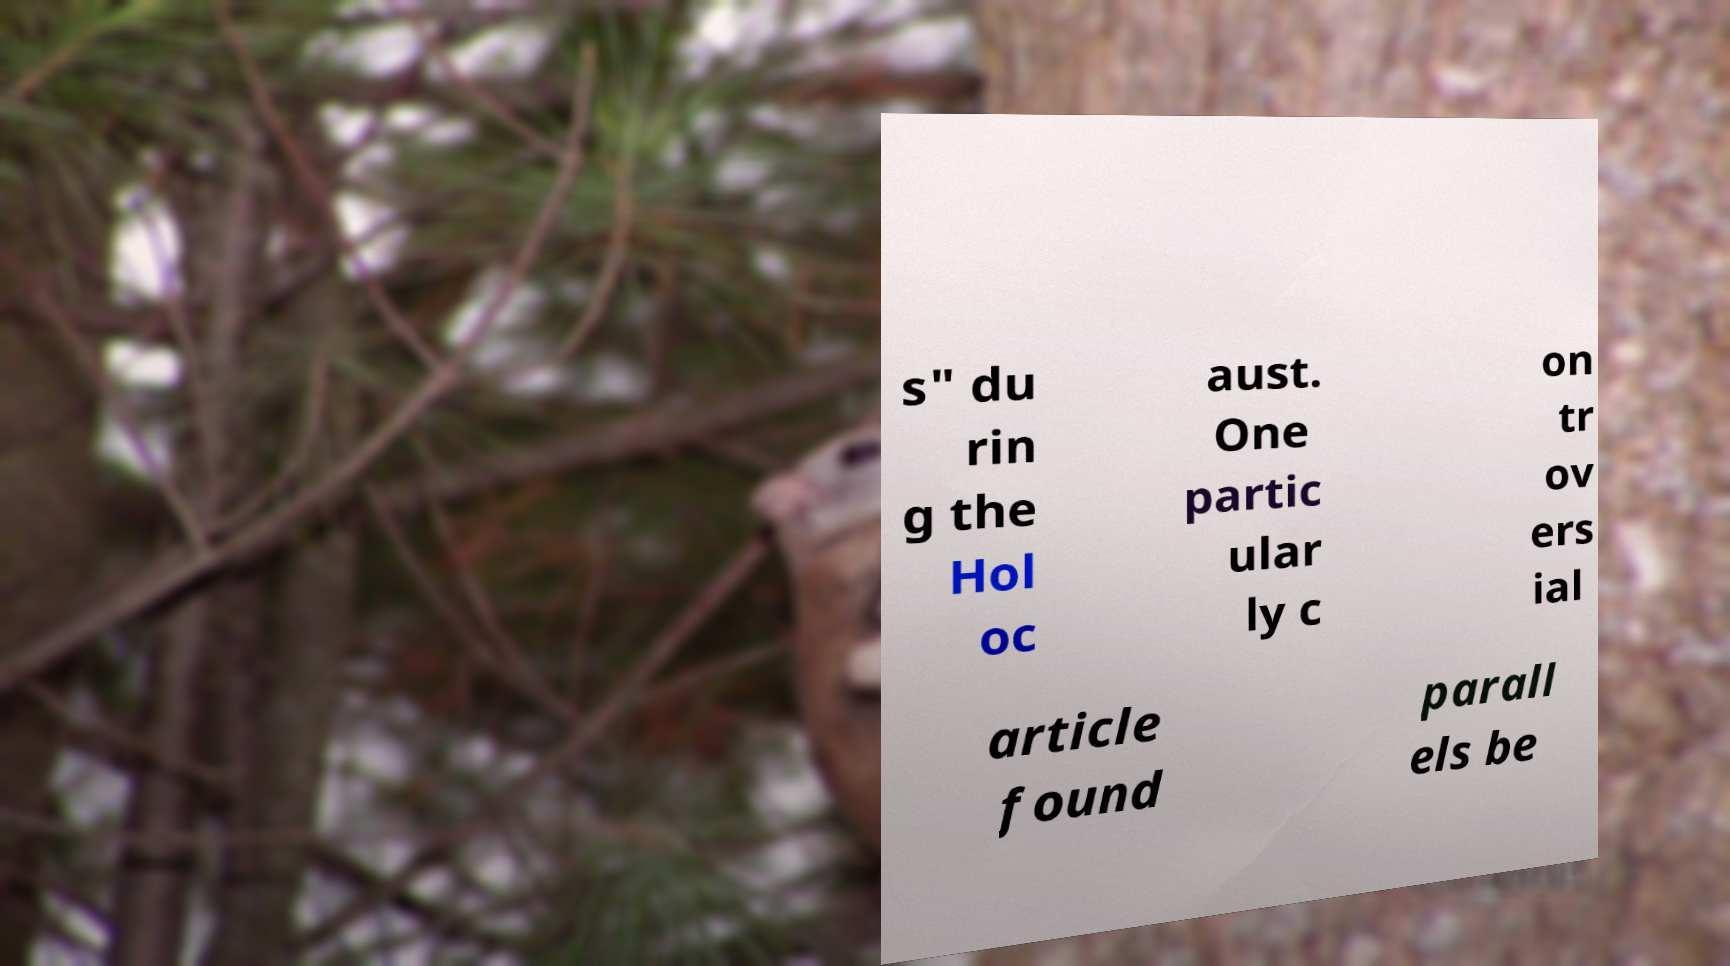Can you accurately transcribe the text from the provided image for me? s" du rin g the Hol oc aust. One partic ular ly c on tr ov ers ial article found parall els be 